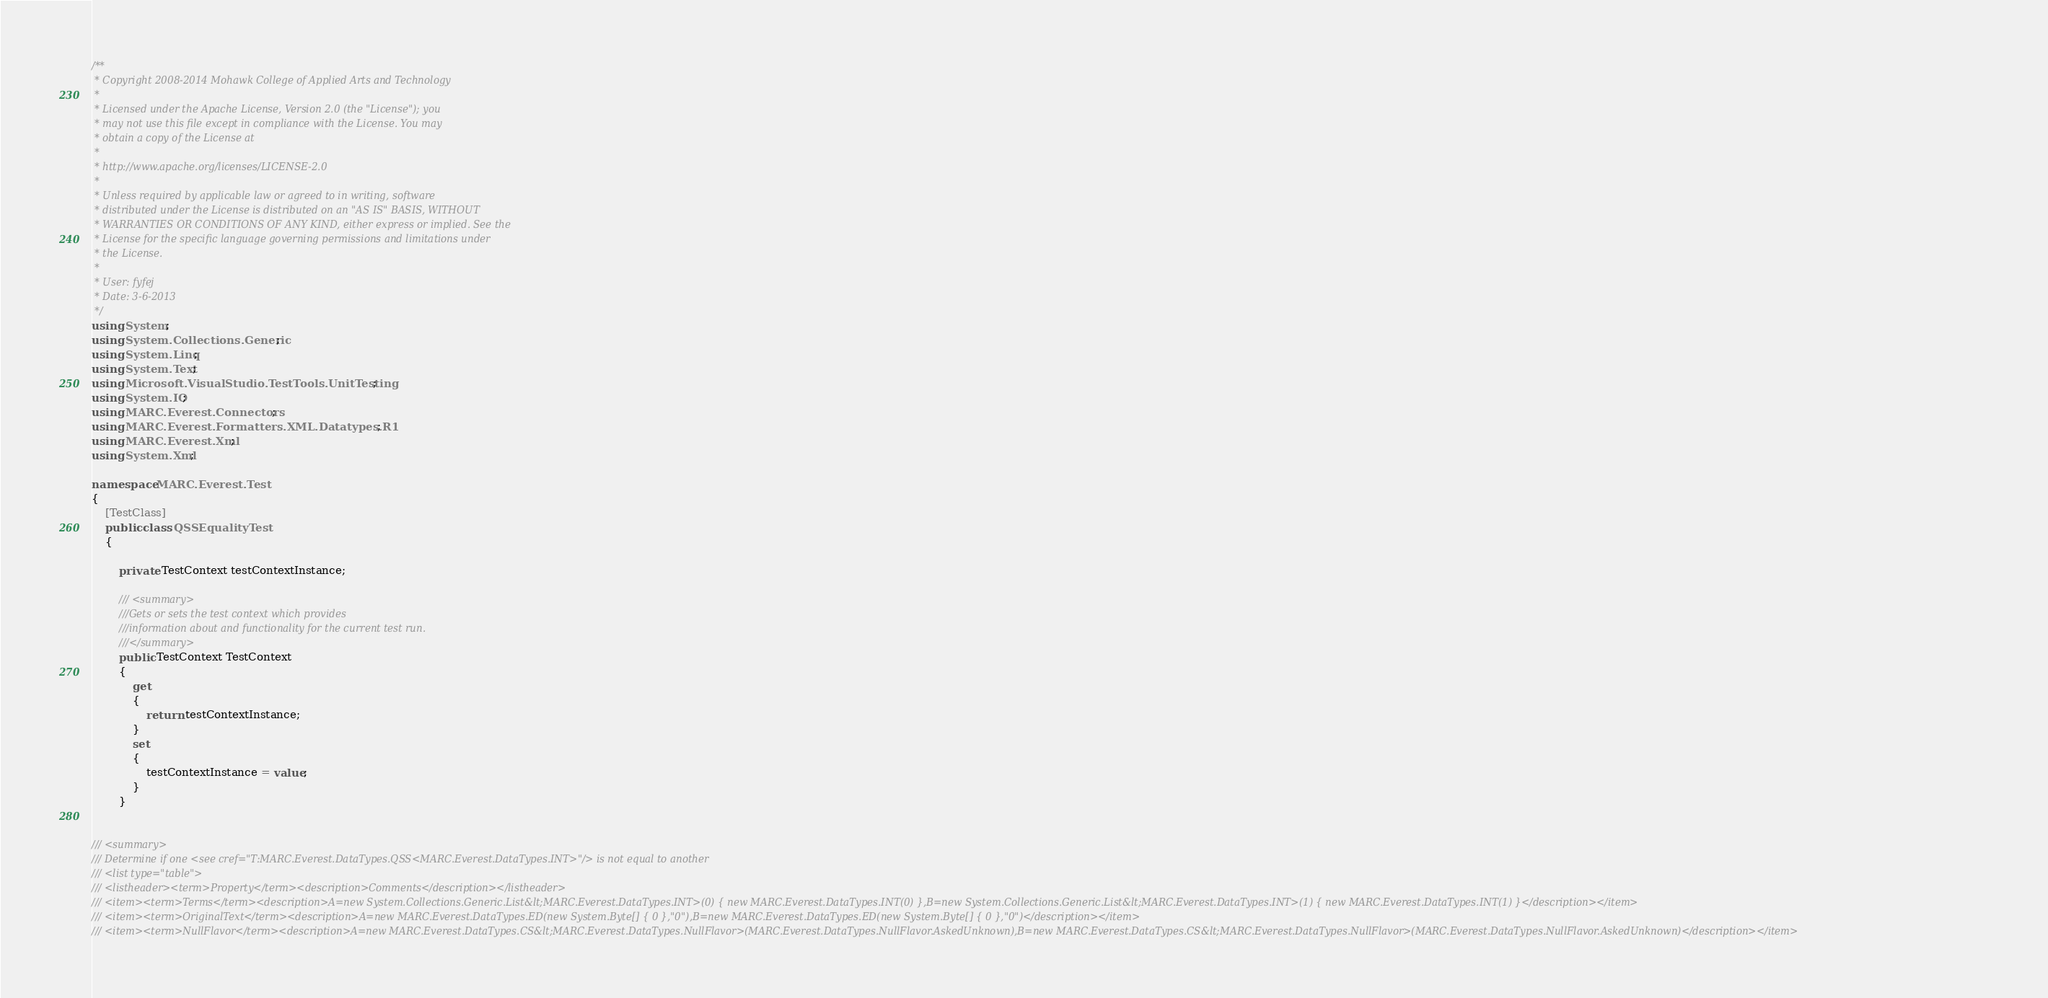Convert code to text. <code><loc_0><loc_0><loc_500><loc_500><_C#_>/**
 * Copyright 2008-2014 Mohawk College of Applied Arts and Technology
 * 
 * Licensed under the Apache License, Version 2.0 (the "License"); you 
 * may not use this file except in compliance with the License. You may 
 * obtain a copy of the License at 
 * 
 * http://www.apache.org/licenses/LICENSE-2.0 
 * 
 * Unless required by applicable law or agreed to in writing, software
 * distributed under the License is distributed on an "AS IS" BASIS, WITHOUT
 * WARRANTIES OR CONDITIONS OF ANY KIND, either express or implied. See the 
 * License for the specific language governing permissions and limitations under 
 * the License.
 * 
 * User: fyfej
 * Date: 3-6-2013
 */
using System;
using System.Collections.Generic;
using System.Linq;
using System.Text;
using Microsoft.VisualStudio.TestTools.UnitTesting;
using System.IO;
using MARC.Everest.Connectors;
using MARC.Everest.Formatters.XML.Datatypes.R1;
using MARC.Everest.Xml;
using System.Xml;

namespace MARC.Everest.Test
{
    [TestClass]
    public class QSSEqualityTest
    {
		
		private TestContext testContextInstance;

        /// <summary>
        ///Gets or sets the test context which provides
        ///information about and functionality for the current test run.
        ///</summary>
        public TestContext TestContext
        {
            get
            {
                return testContextInstance;
            }
            set
            {
                testContextInstance = value;
            }
        }
        

/// <summary>
/// Determine if one <see cref="T:MARC.Everest.DataTypes.QSS<MARC.Everest.DataTypes.INT>"/> is not equal to another
/// <list type="table">
/// <listheader><term>Property</term><description>Comments</description></listheader>
/// <item><term>Terms</term><description>A=new System.Collections.Generic.List&lt;MARC.Everest.DataTypes.INT>(0) { new MARC.Everest.DataTypes.INT(0) },B=new System.Collections.Generic.List&lt;MARC.Everest.DataTypes.INT>(1) { new MARC.Everest.DataTypes.INT(1) }</description></item>
/// <item><term>OriginalText</term><description>A=new MARC.Everest.DataTypes.ED(new System.Byte[] { 0 },"0"),B=new MARC.Everest.DataTypes.ED(new System.Byte[] { 0 },"0")</description></item>
/// <item><term>NullFlavor</term><description>A=new MARC.Everest.DataTypes.CS&lt;MARC.Everest.DataTypes.NullFlavor>(MARC.Everest.DataTypes.NullFlavor.AskedUnknown),B=new MARC.Everest.DataTypes.CS&lt;MARC.Everest.DataTypes.NullFlavor>(MARC.Everest.DataTypes.NullFlavor.AskedUnknown)</description></item></code> 